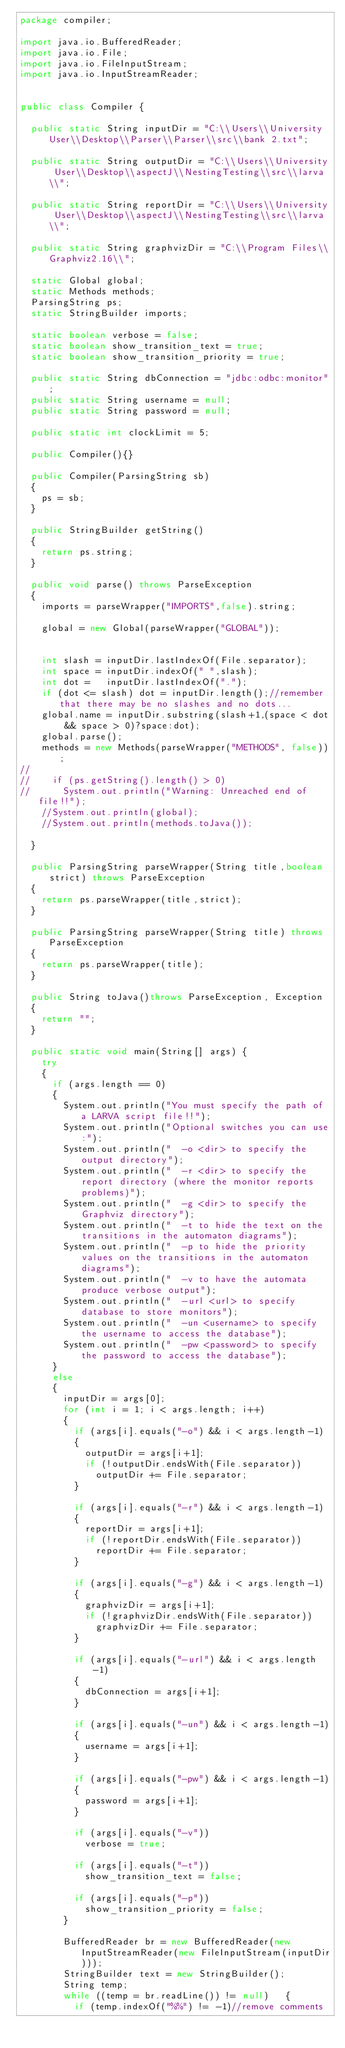Convert code to text. <code><loc_0><loc_0><loc_500><loc_500><_Java_>package compiler;

import java.io.BufferedReader;
import java.io.File;
import java.io.FileInputStream;
import java.io.InputStreamReader;


public class Compiler {

	public static String inputDir = "C:\\Users\\University User\\Desktop\\Parser\\Parser\\src\\bank 2.txt";
	
	public static String outputDir = "C:\\Users\\University User\\Desktop\\aspectJ\\NestingTesting\\src\\larva\\";
	
	public static String reportDir = "C:\\Users\\University User\\Desktop\\aspectJ\\NestingTesting\\src\\larva\\";
	
	public static String graphvizDir = "C:\\Program Files\\Graphviz2.16\\";
	
	static Global global;
	static Methods methods;
	ParsingString ps;
	static StringBuilder imports;
	
	static boolean verbose = false;
	static boolean show_transition_text = true;
	static boolean show_transition_priority = true;
	
	public static String dbConnection = "jdbc:odbc:monitor";
	public static String username = null;
	public static String password = null;
	
	public static int clockLimit = 5;
	
	public Compiler(){}
	
	public Compiler(ParsingString sb)
	{
		ps = sb;
	}
	
	public StringBuilder getString()
	{
		return ps.string;
	}
		
	public void parse() throws ParseException
	{
		imports = parseWrapper("IMPORTS",false).string;
		
		global = new Global(parseWrapper("GLOBAL"));
		
		
		int slash = inputDir.lastIndexOf(File.separator);
		int space = inputDir.indexOf(" ",slash);
		int dot = 	inputDir.lastIndexOf(".");
		if (dot <= slash) dot = inputDir.length();//remember that there may be no slashes and no dots...
		global.name = inputDir.substring(slash+1,(space < dot && space > 0)?space:dot);
		global.parse();
		methods = new Methods(parseWrapper("METHODS", false));
//		
//		if (ps.getString().length() > 0)
//			System.out.println("Warning: Unreached end of file!!");
		//System.out.println(global);
		//System.out.println(methods.toJava());
		
	}
	
	public ParsingString parseWrapper(String title,boolean strict) throws ParseException
	{
		return ps.parseWrapper(title,strict);
	}
	
	public ParsingString parseWrapper(String title) throws ParseException
	{
		return ps.parseWrapper(title);
	}
	
	public String toJava()throws ParseException, Exception
	{
		return "";
	}
	
	public static void main(String[] args) {
		try
		{
			if (args.length == 0)
			{
				System.out.println("You must specify the path of a LARVA script file!!");
				System.out.println("Optional switches you can use:");
				System.out.println("  -o <dir> to specify the output directory");
				System.out.println("  -r <dir> to specify the report directory (where the monitor reports problems)");
				System.out.println("  -g <dir> to specify the Graphviz directory");
				System.out.println("  -t to hide the text on the transitions in the automaton diagrams");
				System.out.println("  -p to hide the priority values on the transitions in the automaton diagrams");
				System.out.println("  -v to have the automata produce verbose output");				
				System.out.println("  -url <url> to specify database to store monitors");				
				System.out.println("  -un <username> to specify the username to access the database");				
				System.out.println("  -pw <password> to specify the password to access the database");				
			}
			else
			{
				inputDir = args[0];
				for (int i = 1; i < args.length; i++)
				{
					if (args[i].equals("-o") && i < args.length-1)
					{
						outputDir = args[i+1];
						if (!outputDir.endsWith(File.separator))
							outputDir += File.separator;
					}
					
					if (args[i].equals("-r") && i < args.length-1)
					{
						reportDir = args[i+1];
						if (!reportDir.endsWith(File.separator))
							reportDir += File.separator;
					}
				
					if (args[i].equals("-g") && i < args.length-1)
					{
						graphvizDir = args[i+1];
						if (!graphvizDir.endsWith(File.separator))
							graphvizDir += File.separator;
					}
					
					if (args[i].equals("-url") && i < args.length-1)
					{
						dbConnection = args[i+1];
					}
					
					if (args[i].equals("-un") && i < args.length-1)
					{
						username = args[i+1];
					}
					
					if (args[i].equals("-pw") && i < args.length-1)
					{
						password = args[i+1];
					}
					
					if (args[i].equals("-v"))
						verbose = true;
					
					if (args[i].equals("-t"))
						show_transition_text = false;
					
					if (args[i].equals("-p"))
						show_transition_priority = false;
				}
				
				BufferedReader br = new BufferedReader(new InputStreamReader(new FileInputStream(inputDir)));
				StringBuilder text = new StringBuilder();
				String temp;
				while ((temp = br.readLine()) != null)   {
					if (temp.indexOf("%%") != -1)//remove comments</code> 